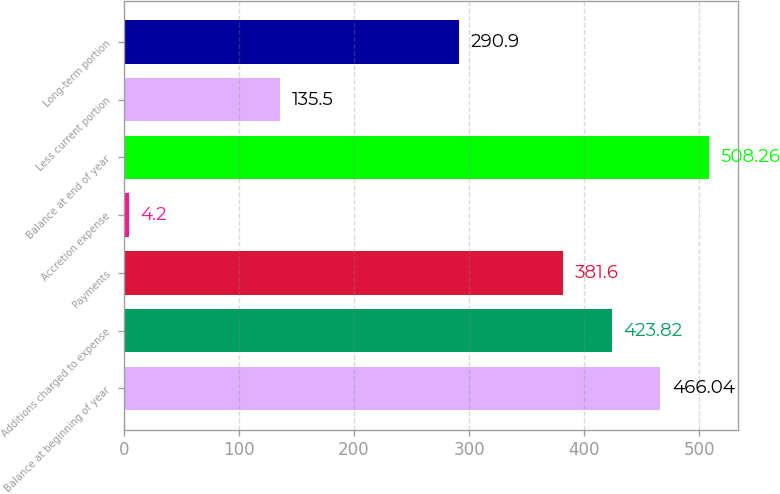Convert chart to OTSL. <chart><loc_0><loc_0><loc_500><loc_500><bar_chart><fcel>Balance at beginning of year<fcel>Additions charged to expense<fcel>Payments<fcel>Accretion expense<fcel>Balance at end of year<fcel>Less current portion<fcel>Long-term portion<nl><fcel>466.04<fcel>423.82<fcel>381.6<fcel>4.2<fcel>508.26<fcel>135.5<fcel>290.9<nl></chart> 